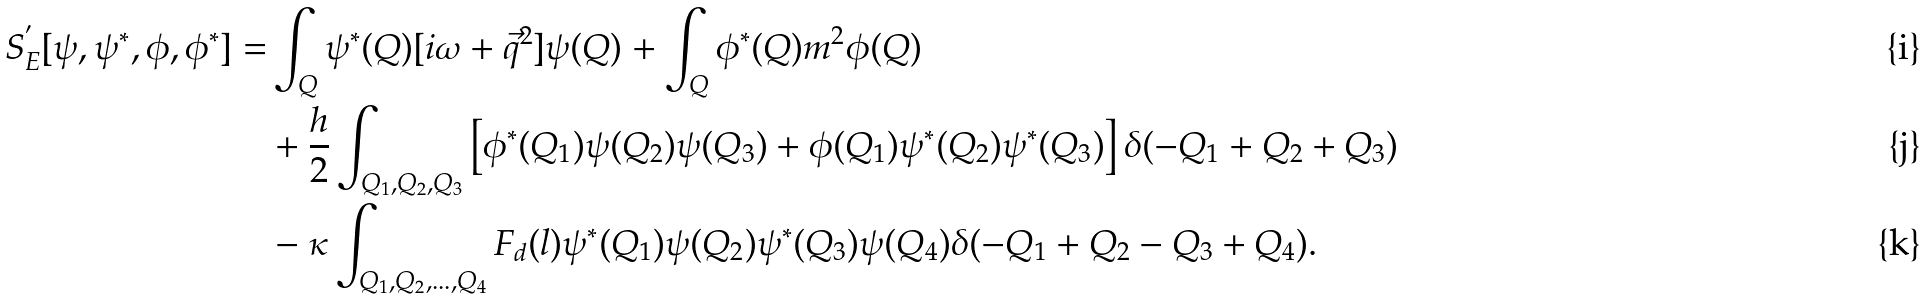<formula> <loc_0><loc_0><loc_500><loc_500>S _ { E } ^ { ^ { \prime } } [ \psi , \psi ^ { * } , \phi , \phi ^ { * } ] = & \int _ { Q } \psi ^ { * } ( Q ) [ i \omega + \vec { q } ^ { 2 } ] \psi ( Q ) + \int _ { Q } \phi ^ { * } ( Q ) m ^ { 2 } \phi ( Q ) \\ & + \frac { h } { 2 } \int _ { Q _ { 1 } , Q _ { 2 } , Q _ { 3 } } \left [ \phi ^ { * } ( Q _ { 1 } ) \psi ( Q _ { 2 } ) \psi ( Q _ { 3 } ) + \phi ( Q _ { 1 } ) \psi ^ { * } ( Q _ { 2 } ) \psi ^ { * } ( Q _ { 3 } ) \right ] \delta ( - Q _ { 1 } + Q _ { 2 } + Q _ { 3 } ) \\ & - \kappa \int _ { Q _ { 1 } , Q _ { 2 } , \dots , Q _ { 4 } } F _ { d } ( l ) \psi ^ { * } ( Q _ { 1 } ) \psi ( Q _ { 2 } ) \psi ^ { * } ( Q _ { 3 } ) \psi ( Q _ { 4 } ) \delta ( - Q _ { 1 } + Q _ { 2 } - Q _ { 3 } + Q _ { 4 } ) .</formula> 